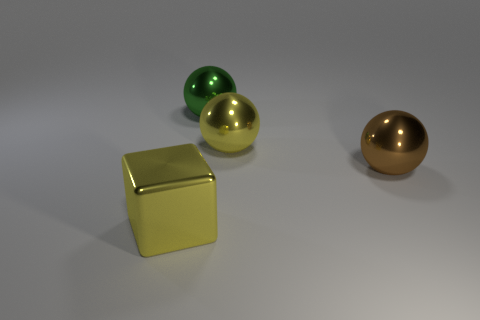How big is the object that is to the right of the big yellow shiny thing on the right side of the large yellow metal thing that is to the left of the large yellow ball?
Your answer should be compact. Large. Is the number of big spheres that are right of the green sphere the same as the number of big green matte objects?
Your answer should be very brief. No. Is there any other thing that is the same shape as the large brown shiny object?
Provide a short and direct response. Yes. There is a green metal thing; does it have the same shape as the brown metallic thing that is in front of the big yellow sphere?
Your response must be concise. Yes. There is a brown metal object that is the same shape as the large green metallic object; what size is it?
Your answer should be very brief. Large. How many other objects are the same material as the green thing?
Provide a succinct answer. 3. What material is the large yellow sphere?
Offer a very short reply. Metal. Is the color of the metallic object in front of the big brown sphere the same as the metal thing to the right of the large yellow sphere?
Make the answer very short. No. Is the number of big yellow metal blocks behind the large yellow cube greater than the number of big yellow things?
Your answer should be very brief. No. How many other objects are the same color as the block?
Offer a very short reply. 1. 